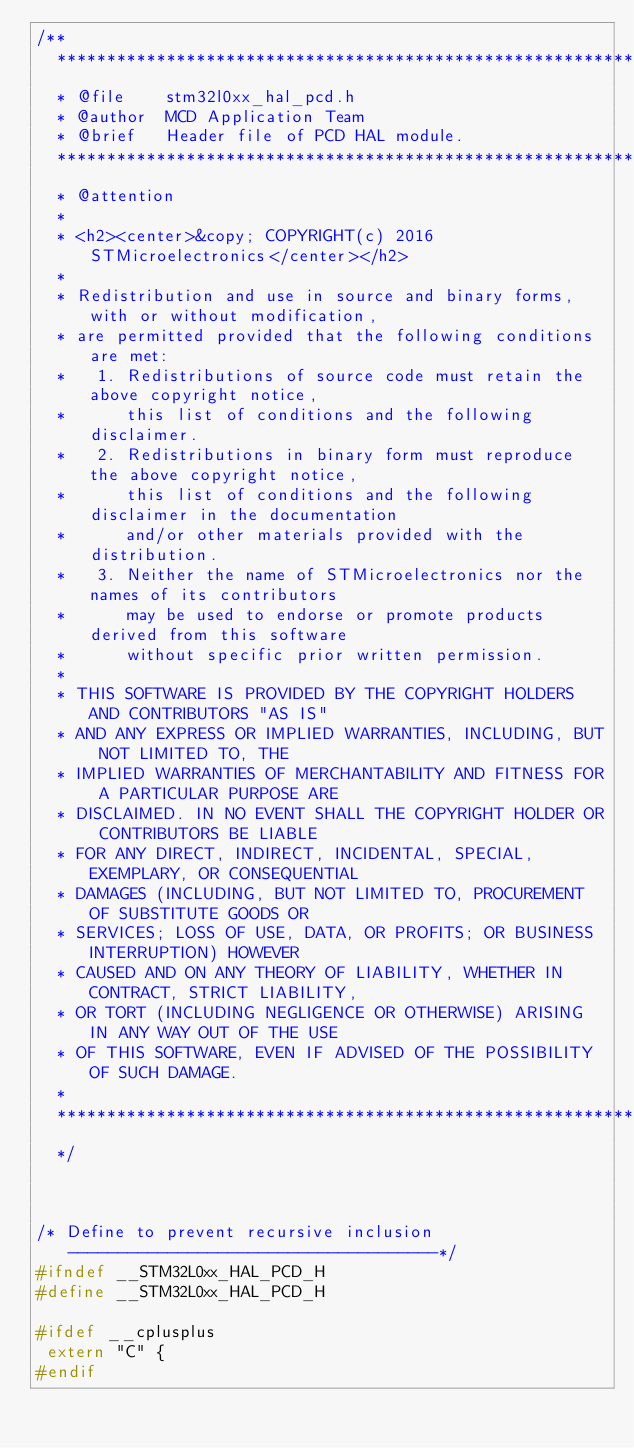Convert code to text. <code><loc_0><loc_0><loc_500><loc_500><_C_>/**
  ******************************************************************************
  * @file    stm32l0xx_hal_pcd.h
  * @author  MCD Application Team
  * @brief   Header file of PCD HAL module.
  ******************************************************************************
  * @attention
  *
  * <h2><center>&copy; COPYRIGHT(c) 2016 STMicroelectronics</center></h2>
  *
  * Redistribution and use in source and binary forms, with or without modification,
  * are permitted provided that the following conditions are met:
  *   1. Redistributions of source code must retain the above copyright notice,
  *      this list of conditions and the following disclaimer.
  *   2. Redistributions in binary form must reproduce the above copyright notice,
  *      this list of conditions and the following disclaimer in the documentation
  *      and/or other materials provided with the distribution.
  *   3. Neither the name of STMicroelectronics nor the names of its contributors
  *      may be used to endorse or promote products derived from this software
  *      without specific prior written permission.
  *
  * THIS SOFTWARE IS PROVIDED BY THE COPYRIGHT HOLDERS AND CONTRIBUTORS "AS IS"
  * AND ANY EXPRESS OR IMPLIED WARRANTIES, INCLUDING, BUT NOT LIMITED TO, THE
  * IMPLIED WARRANTIES OF MERCHANTABILITY AND FITNESS FOR A PARTICULAR PURPOSE ARE
  * DISCLAIMED. IN NO EVENT SHALL THE COPYRIGHT HOLDER OR CONTRIBUTORS BE LIABLE
  * FOR ANY DIRECT, INDIRECT, INCIDENTAL, SPECIAL, EXEMPLARY, OR CONSEQUENTIAL
  * DAMAGES (INCLUDING, BUT NOT LIMITED TO, PROCUREMENT OF SUBSTITUTE GOODS OR
  * SERVICES; LOSS OF USE, DATA, OR PROFITS; OR BUSINESS INTERRUPTION) HOWEVER
  * CAUSED AND ON ANY THEORY OF LIABILITY, WHETHER IN CONTRACT, STRICT LIABILITY,
  * OR TORT (INCLUDING NEGLIGENCE OR OTHERWISE) ARISING IN ANY WAY OUT OF THE USE
  * OF THIS SOFTWARE, EVEN IF ADVISED OF THE POSSIBILITY OF SUCH DAMAGE.
  *
  ******************************************************************************
  */ 



/* Define to prevent recursive inclusion -------------------------------------*/
#ifndef __STM32L0xx_HAL_PCD_H
#define __STM32L0xx_HAL_PCD_H

#ifdef __cplusplus
 extern "C" {
#endif
</code> 